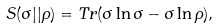Convert formula to latex. <formula><loc_0><loc_0><loc_500><loc_500>S ( \sigma | | \rho ) = T r ( \sigma \ln \sigma - \sigma \ln \rho ) ,</formula> 